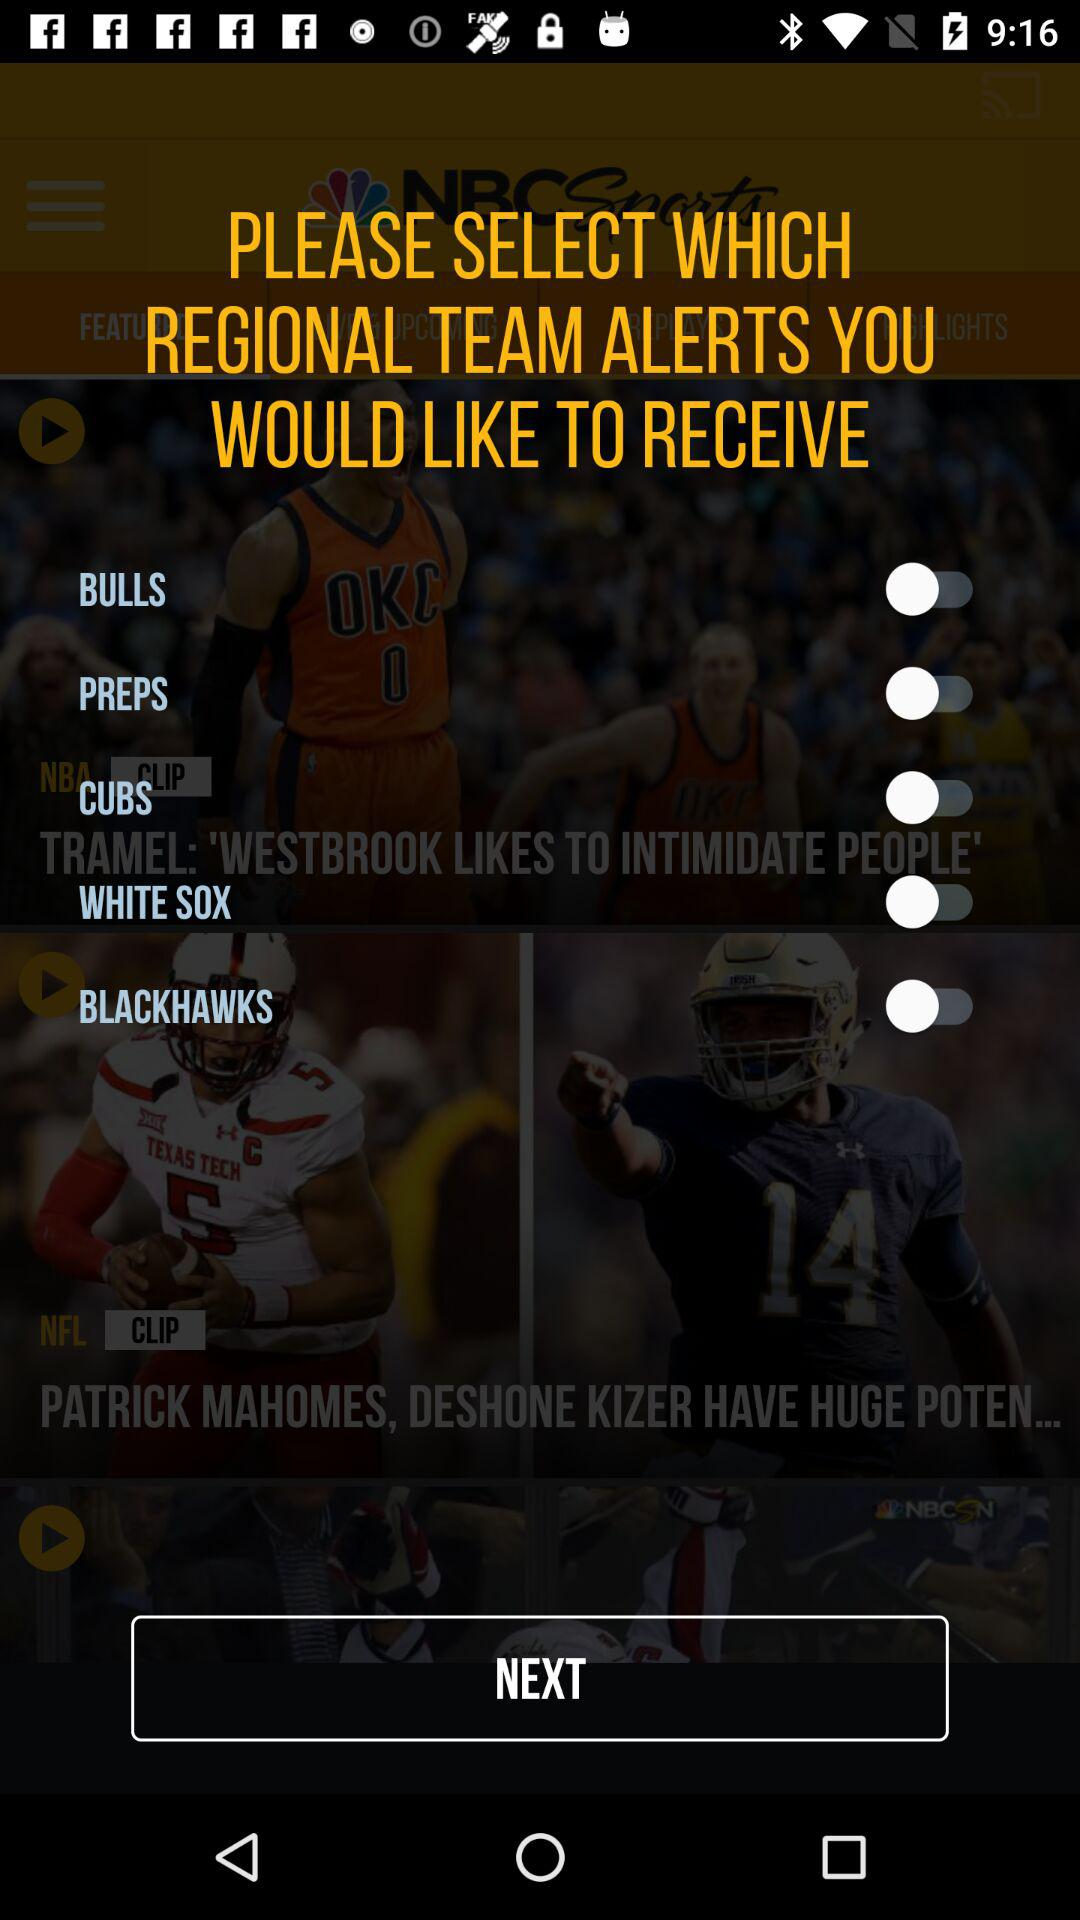What is the status of "CUBS"? The status of "CUBS" is "off". 